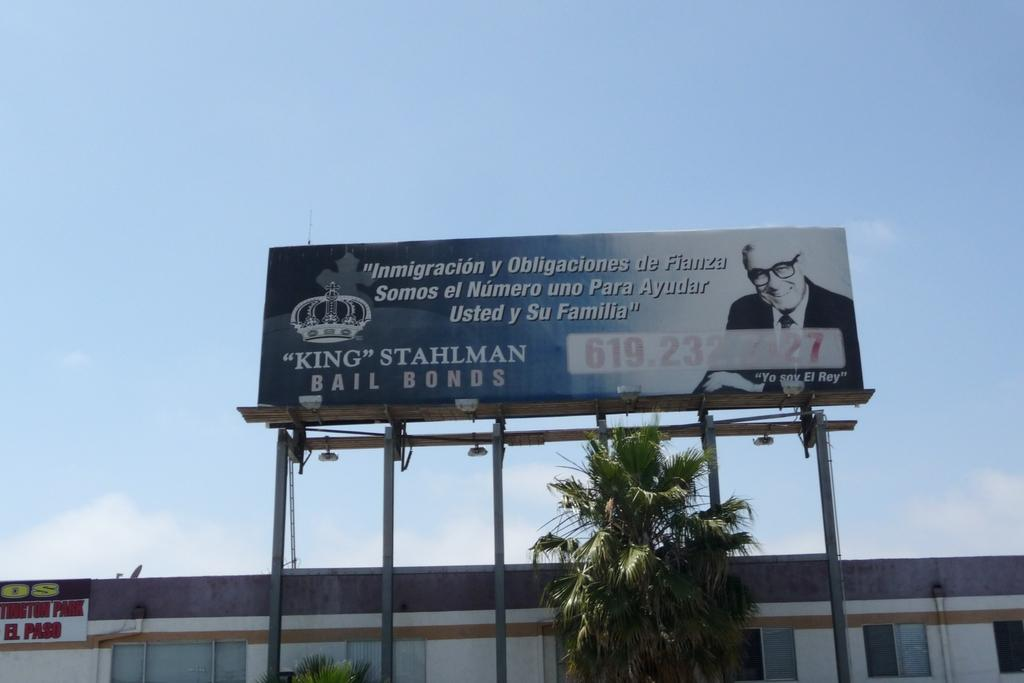<image>
Describe the image concisely. A blue billboard reads "KING STAHLMAN BAIL BONDS." 